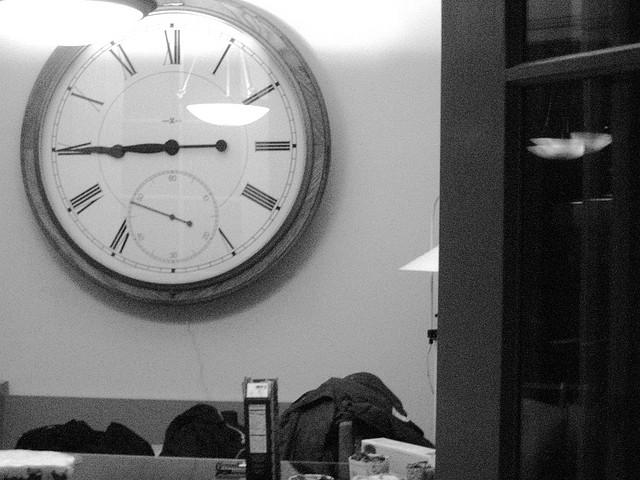What does the time on the clock on the left say it is?
Be succinct. 8:45. Are the hands on these clocks all in the same position?
Give a very brief answer. Yes. What is the clock attached to?
Be succinct. Wall. What time is it?
Keep it brief. 8:45. Is there any color in this picture?
Give a very brief answer. No. What is reflecting in the ringer of the clock?
Quick response, please. Light. Is the face of the clock the same color as the wall?
Concise answer only. Yes. How many clocks on the wall?
Be succinct. 1. Are the Roman numerals on the clock correct?
Answer briefly. Yes. Why would someone have a clock in this style?
Be succinct. They like it. What time is on the clock?
Give a very brief answer. 2:45. 